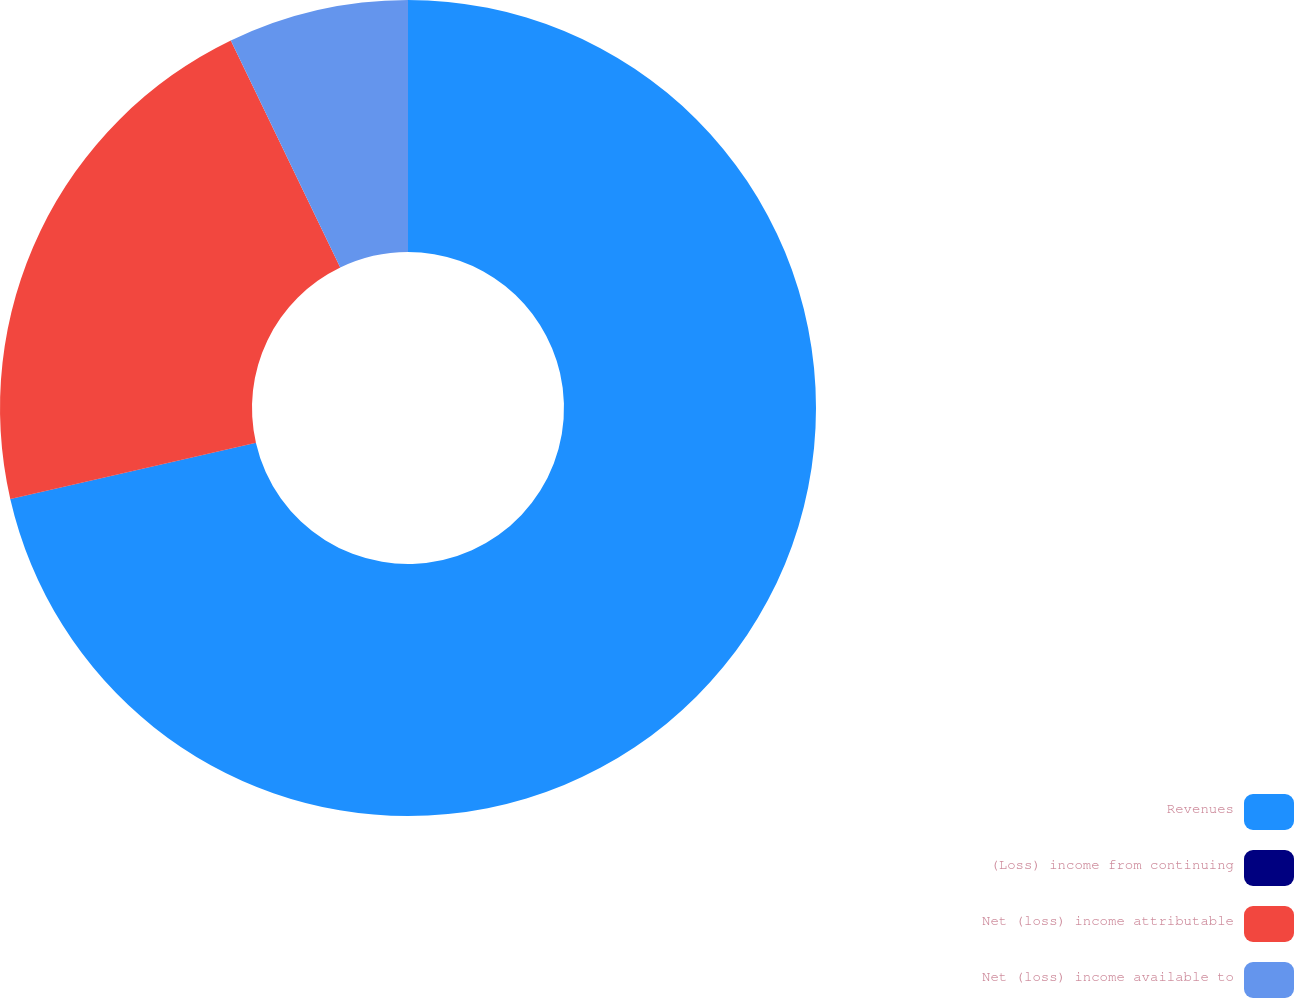Convert chart to OTSL. <chart><loc_0><loc_0><loc_500><loc_500><pie_chart><fcel>Revenues<fcel>(Loss) income from continuing<fcel>Net (loss) income attributable<fcel>Net (loss) income available to<nl><fcel>71.41%<fcel>0.01%<fcel>21.43%<fcel>7.15%<nl></chart> 